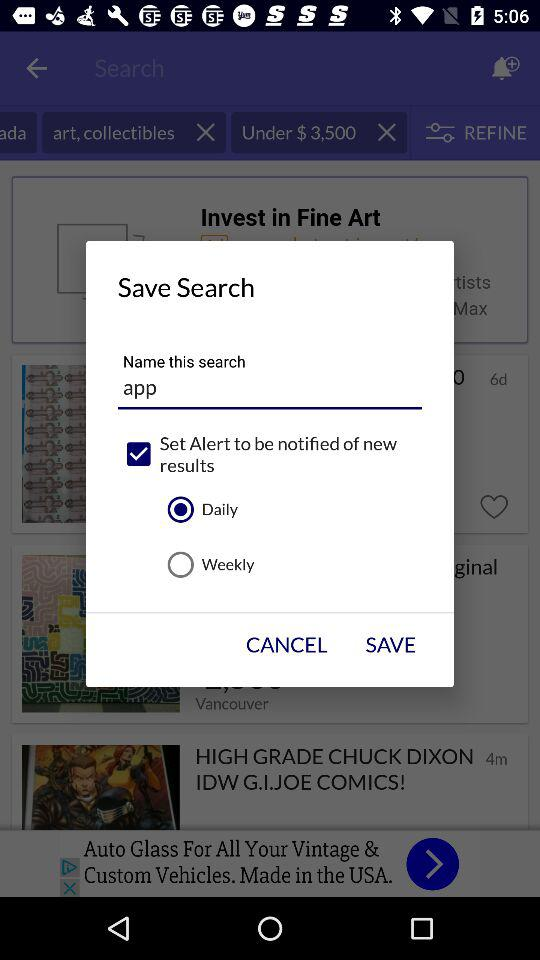How many bikes are there? There are 46,581 bikes. 